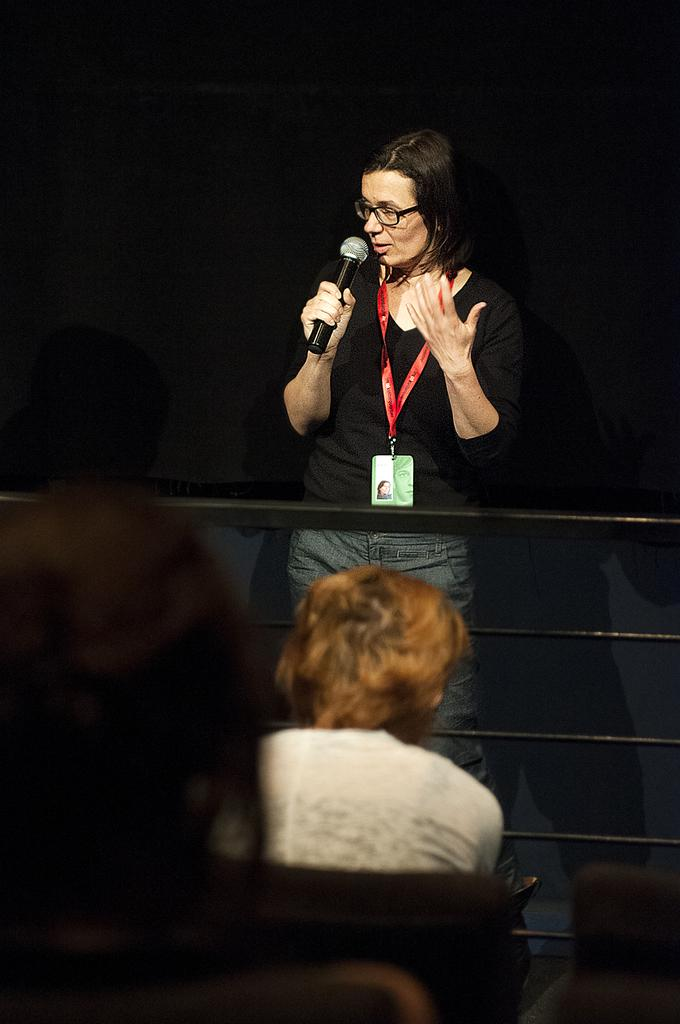What is the woman doing on stage in the image? The woman is standing on stage and speaking on a microphone. Who else is present in the image? There are other people sitting behind the woman. What are the people doing in the image? The people are staring at the woman. Where is the woman's bedroom located in the image? There is no bedroom present in the image; it features a woman standing on stage and speaking on a microphone. Is the woman sleeping in the image? No, the woman is not sleeping in the image; she is standing on stage and speaking on a microphone. 